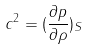<formula> <loc_0><loc_0><loc_500><loc_500>c ^ { 2 } = ( \frac { \partial p } { \partial \rho } ) _ { S }</formula> 